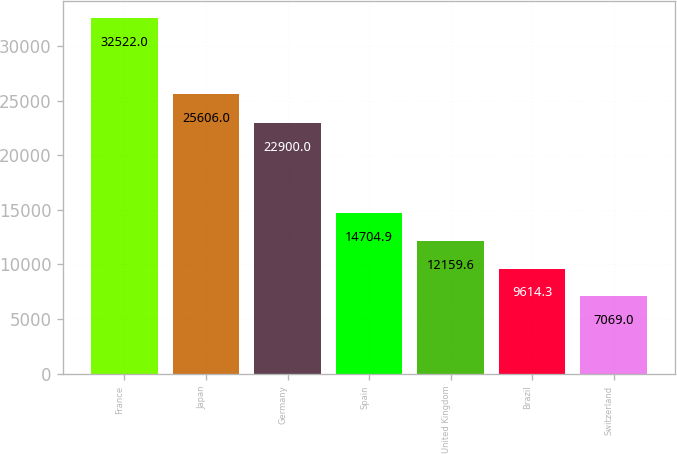Convert chart. <chart><loc_0><loc_0><loc_500><loc_500><bar_chart><fcel>France<fcel>Japan<fcel>Germany<fcel>Spain<fcel>United Kingdom<fcel>Brazil<fcel>Switzerland<nl><fcel>32522<fcel>25606<fcel>22900<fcel>14704.9<fcel>12159.6<fcel>9614.3<fcel>7069<nl></chart> 